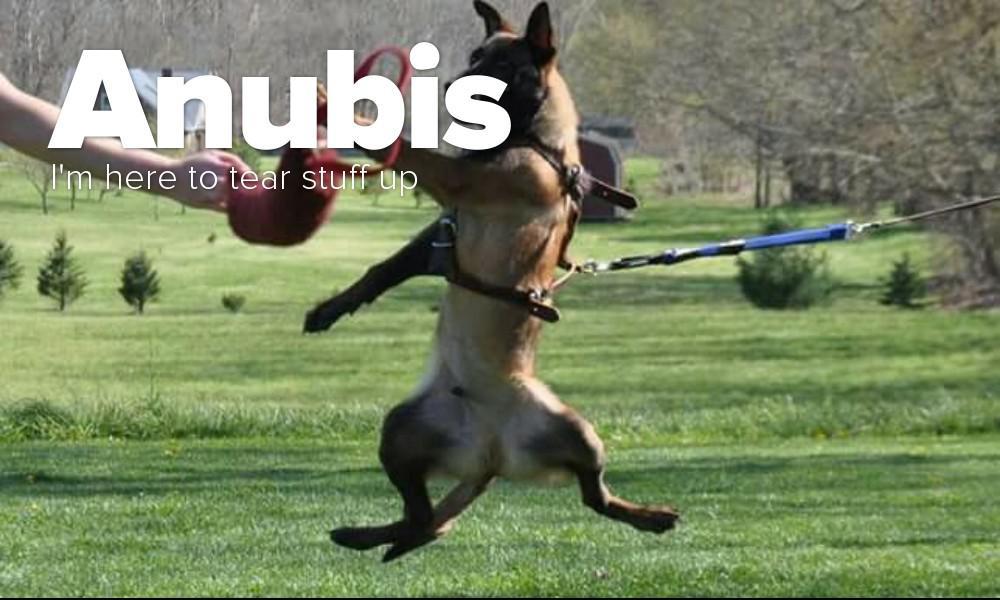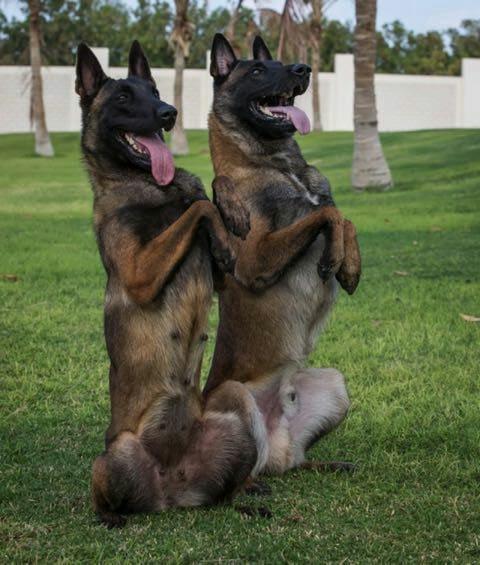The first image is the image on the left, the second image is the image on the right. Assess this claim about the two images: "An image shows exactly one german shepherd, which is sitting on the grass.". Correct or not? Answer yes or no. No. The first image is the image on the left, the second image is the image on the right. Assess this claim about the two images: "In one of the images there is a dog attached to a leash.". Correct or not? Answer yes or no. Yes. 